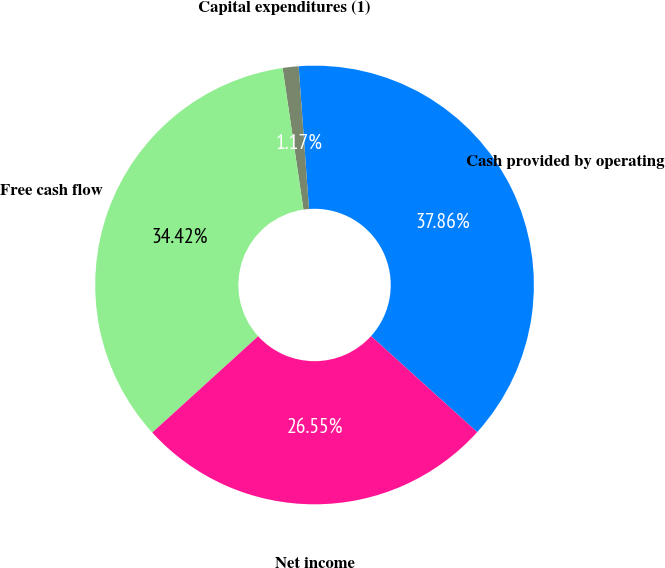Convert chart to OTSL. <chart><loc_0><loc_0><loc_500><loc_500><pie_chart><fcel>Cash provided by operating<fcel>Capital expenditures (1)<fcel>Free cash flow<fcel>Net income<nl><fcel>37.86%<fcel>1.17%<fcel>34.42%<fcel>26.55%<nl></chart> 